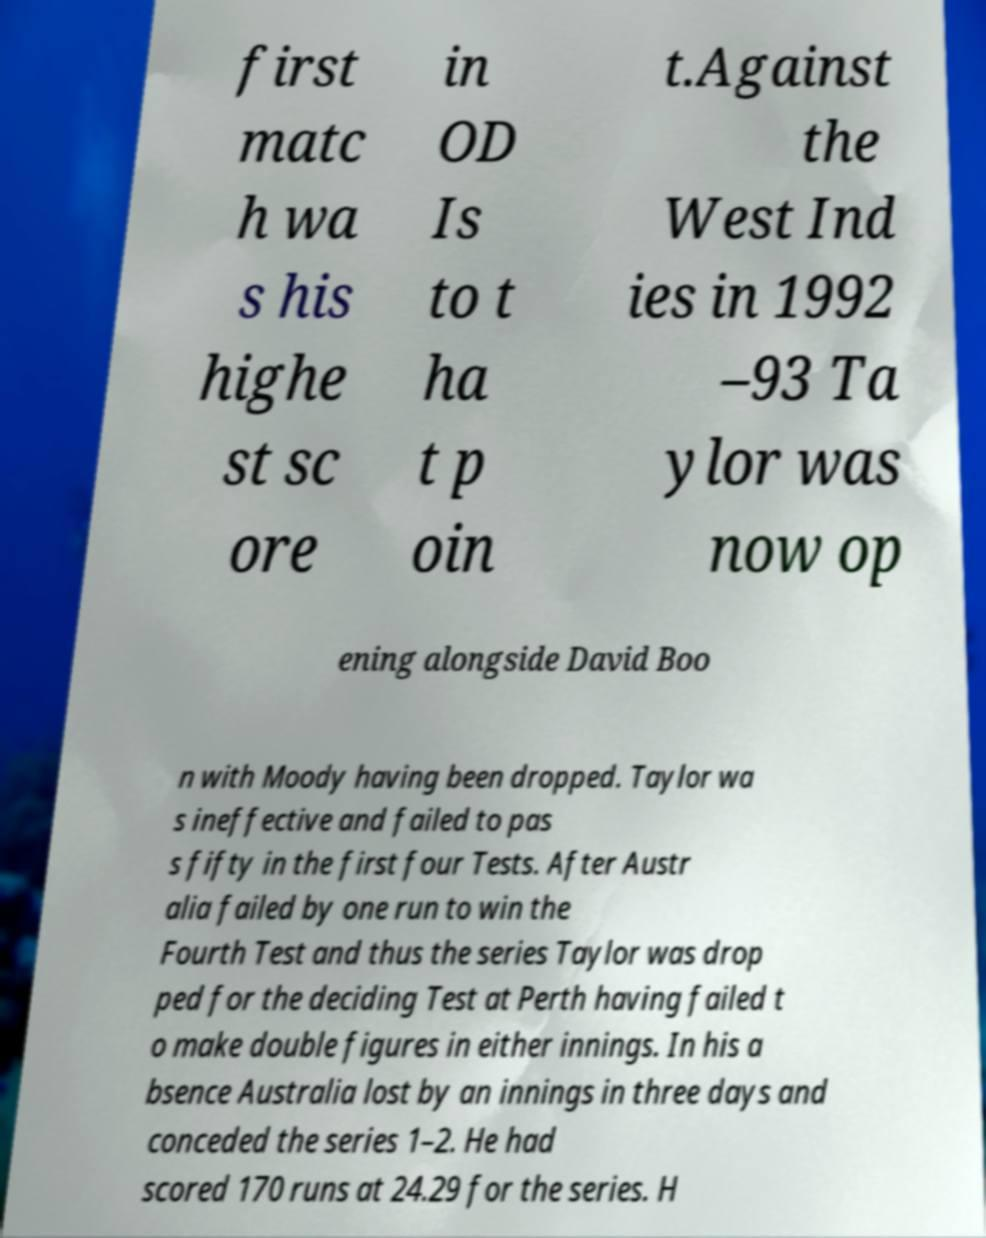There's text embedded in this image that I need extracted. Can you transcribe it verbatim? first matc h wa s his highe st sc ore in OD Is to t ha t p oin t.Against the West Ind ies in 1992 –93 Ta ylor was now op ening alongside David Boo n with Moody having been dropped. Taylor wa s ineffective and failed to pas s fifty in the first four Tests. After Austr alia failed by one run to win the Fourth Test and thus the series Taylor was drop ped for the deciding Test at Perth having failed t o make double figures in either innings. In his a bsence Australia lost by an innings in three days and conceded the series 1–2. He had scored 170 runs at 24.29 for the series. H 